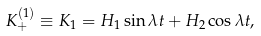Convert formula to latex. <formula><loc_0><loc_0><loc_500><loc_500>K _ { + } ^ { ( 1 ) } \equiv K _ { 1 } = H _ { 1 } \sin \lambda t + H _ { 2 } \cos \lambda t ,</formula> 